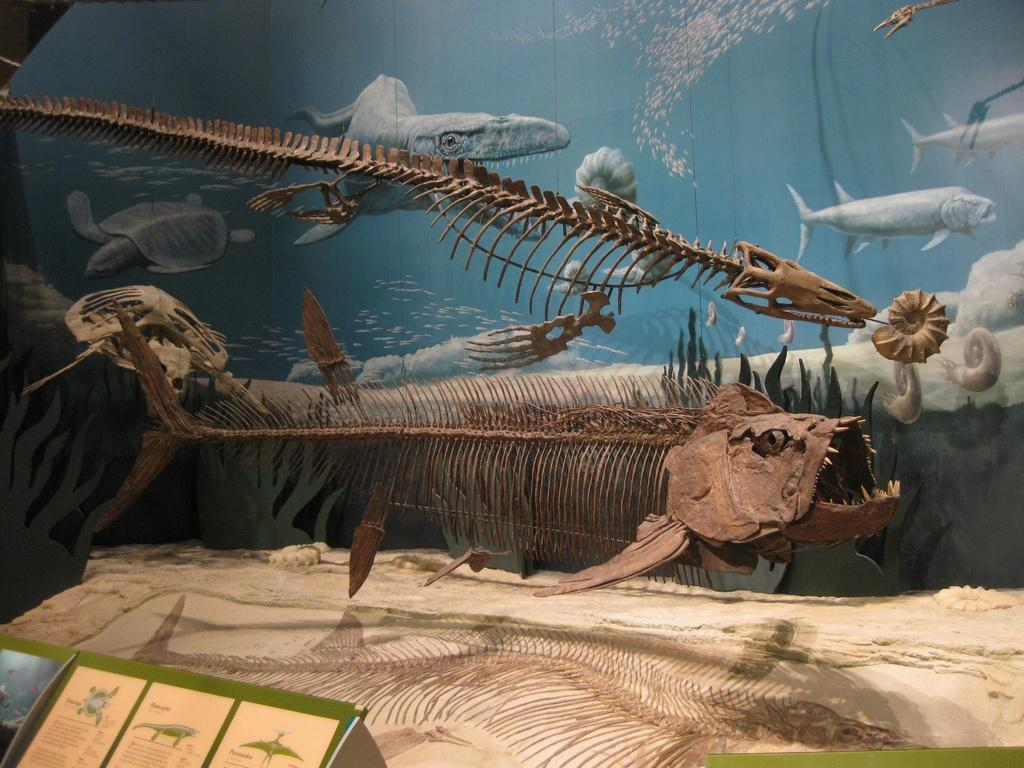What can be seen in the image that resembles the remains of fish? There are fish skeletons in the image. What type of animals can be seen in the background of the image? Snails, a tortoise, and fishes can be seen in the background of the image. What is the environment like in the background of the image? There is water visible in the background of the image. What is the paper with text and images used for in the image? The purpose of the paper with text and images is not specified in the image. What type of net can be seen in the image? There is no net present in the image. Can you tell me how many goats are visible in the image? There are no goats present in the image. 